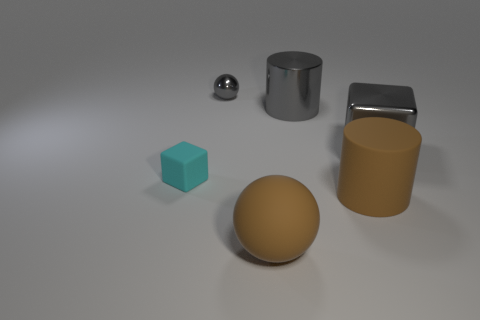Can you describe the arrangement of objects on the surface? Certainly! We notice a plethora of geometrically distinct objects laid out on a flat surface. There's a metallic sphere, a cylindrical block, and a cube, in addition to a larger gold-toned sphere and a cylindrical container with open ends. They are arranged without a specific pattern but are spaced out in a way that each shape is distinct from one another. 